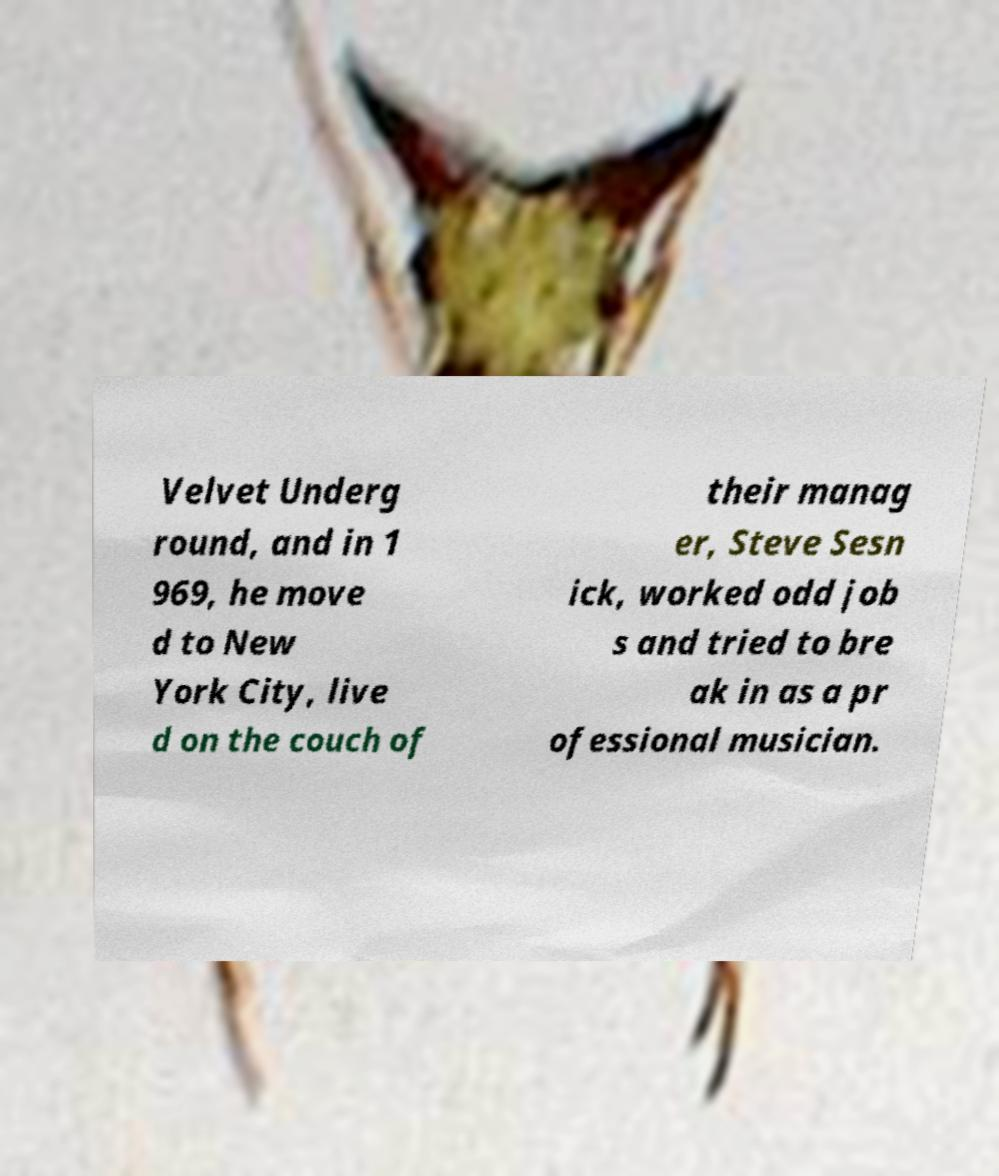I need the written content from this picture converted into text. Can you do that? Velvet Underg round, and in 1 969, he move d to New York City, live d on the couch of their manag er, Steve Sesn ick, worked odd job s and tried to bre ak in as a pr ofessional musician. 